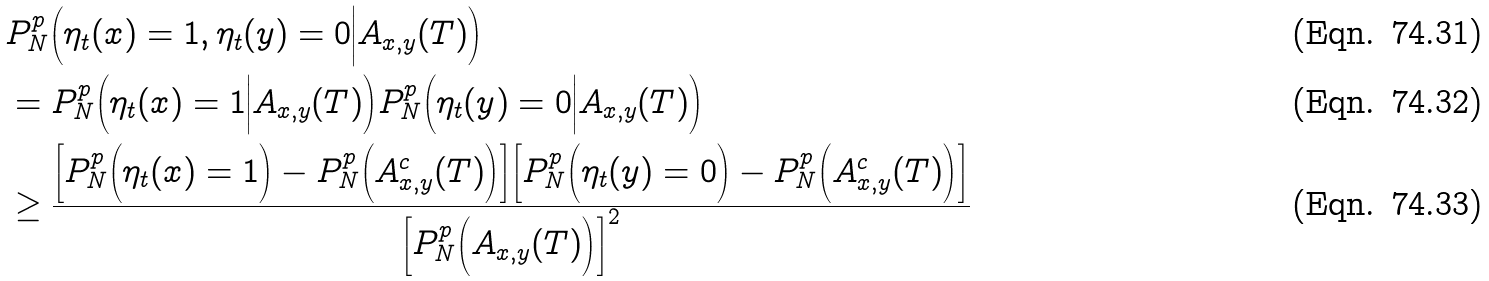<formula> <loc_0><loc_0><loc_500><loc_500>& P _ { N } ^ { p } \Big ( \eta _ { t } ( x ) = 1 , \eta _ { t } ( y ) = 0 \Big | A _ { x , y } ( T ) \Big ) \\ & = P _ { N } ^ { p } \Big ( \eta _ { t } ( x ) = 1 \Big | A _ { x , y } ( T ) \Big ) P _ { N } ^ { p } \Big ( \eta _ { t } ( y ) = 0 \Big | A _ { x , y } ( T ) \Big ) \\ & \geq \frac { \Big [ P _ { N } ^ { p } \Big ( \eta _ { t } ( x ) = 1 \Big ) - P _ { N } ^ { p } \Big ( A ^ { c } _ { x , y } ( T ) \Big ) \Big ] \Big [ P _ { N } ^ { p } \Big ( \eta _ { t } ( y ) = 0 \Big ) - P _ { N } ^ { p } \Big ( A ^ { c } _ { x , y } ( T ) \Big ) \Big ] } { \Big [ P ^ { p } _ { N } \Big ( A _ { x , y } ( T ) \Big ) \Big ] ^ { 2 } }</formula> 